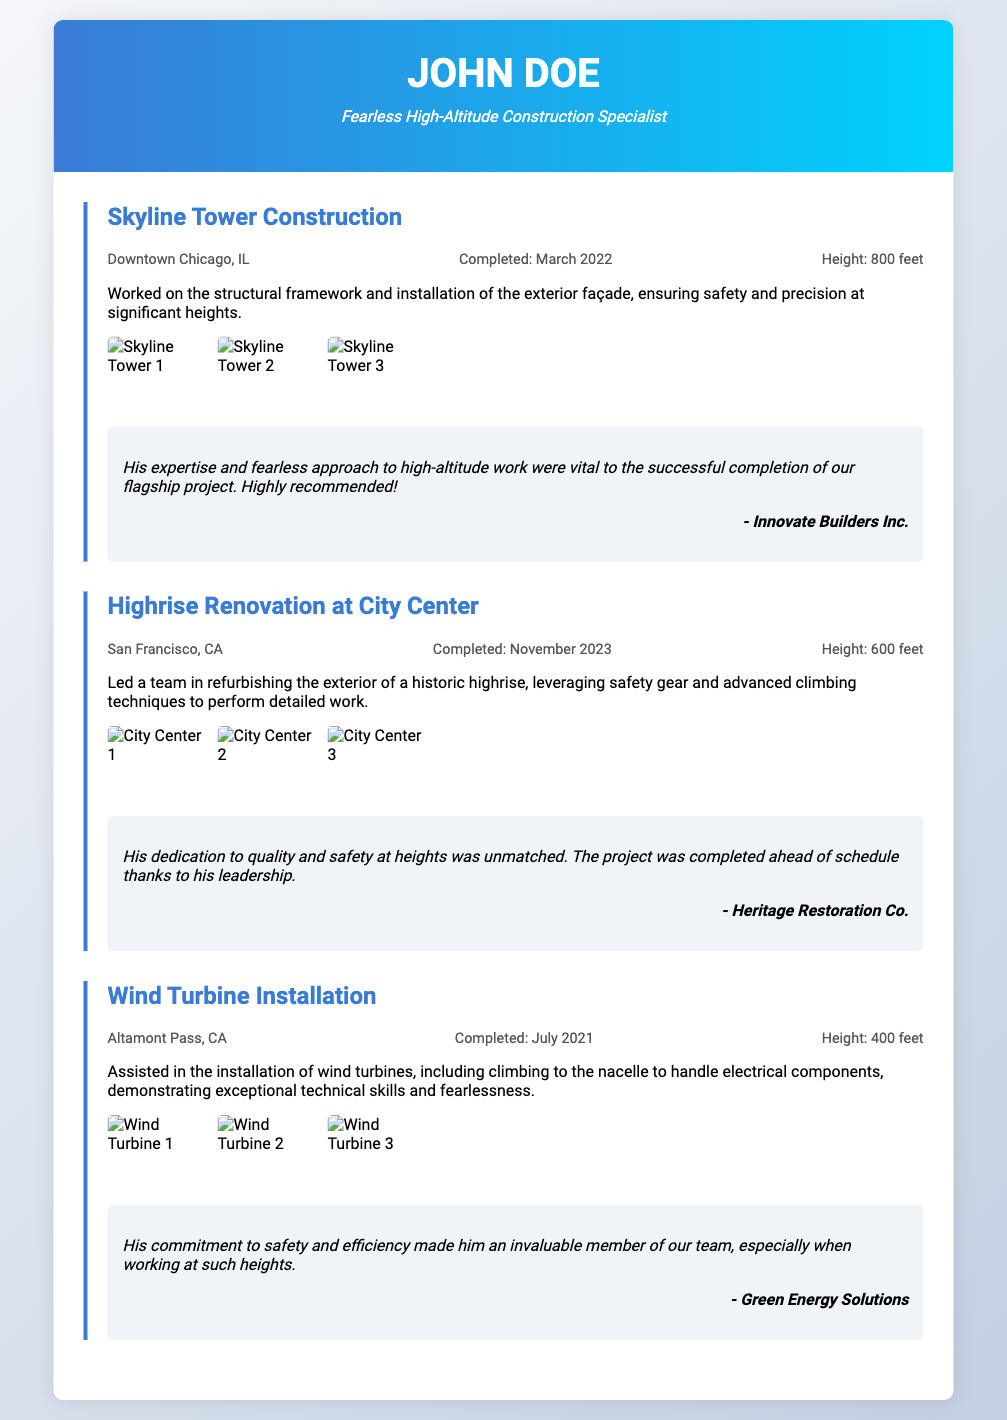what is the name of the first project listed? The name of the first project is found in the project title section of the document.
Answer: Skyline Tower Construction what city is the Skyline Tower located in? The city is mentioned in the project details for the Skyline Tower project.
Answer: Downtown Chicago, IL when was the Highrise Renovation project completed? The completion date is specified in the project details of the Highrise Renovation project.
Answer: November 2023 how tall is the Wind Turbine installation? The height is indicated in the project details for the Wind Turbine Installation.
Answer: 400 feet who was the client for the Skyline Tower Construction project? The client's name is mentioned in the testimonial section related to the Skyline Tower project.
Answer: Innovate Builders Inc what was the focus of the Highrise Renovation project? The focus is provided in the project description for the Highrise Renovation project.
Answer: Refurbishing the exterior how many projects are listed in total? The total number of projects can be counted from the project sections.
Answer: Three what type of documentation is provided for each project? The type of documentation is mentioned in the visual documentation section.
Answer: Images what role did the individual play in the Wind Turbine Installation? The individual's role is described in the project description for the Wind Turbine Installation.
Answer: Assisted in the installation 